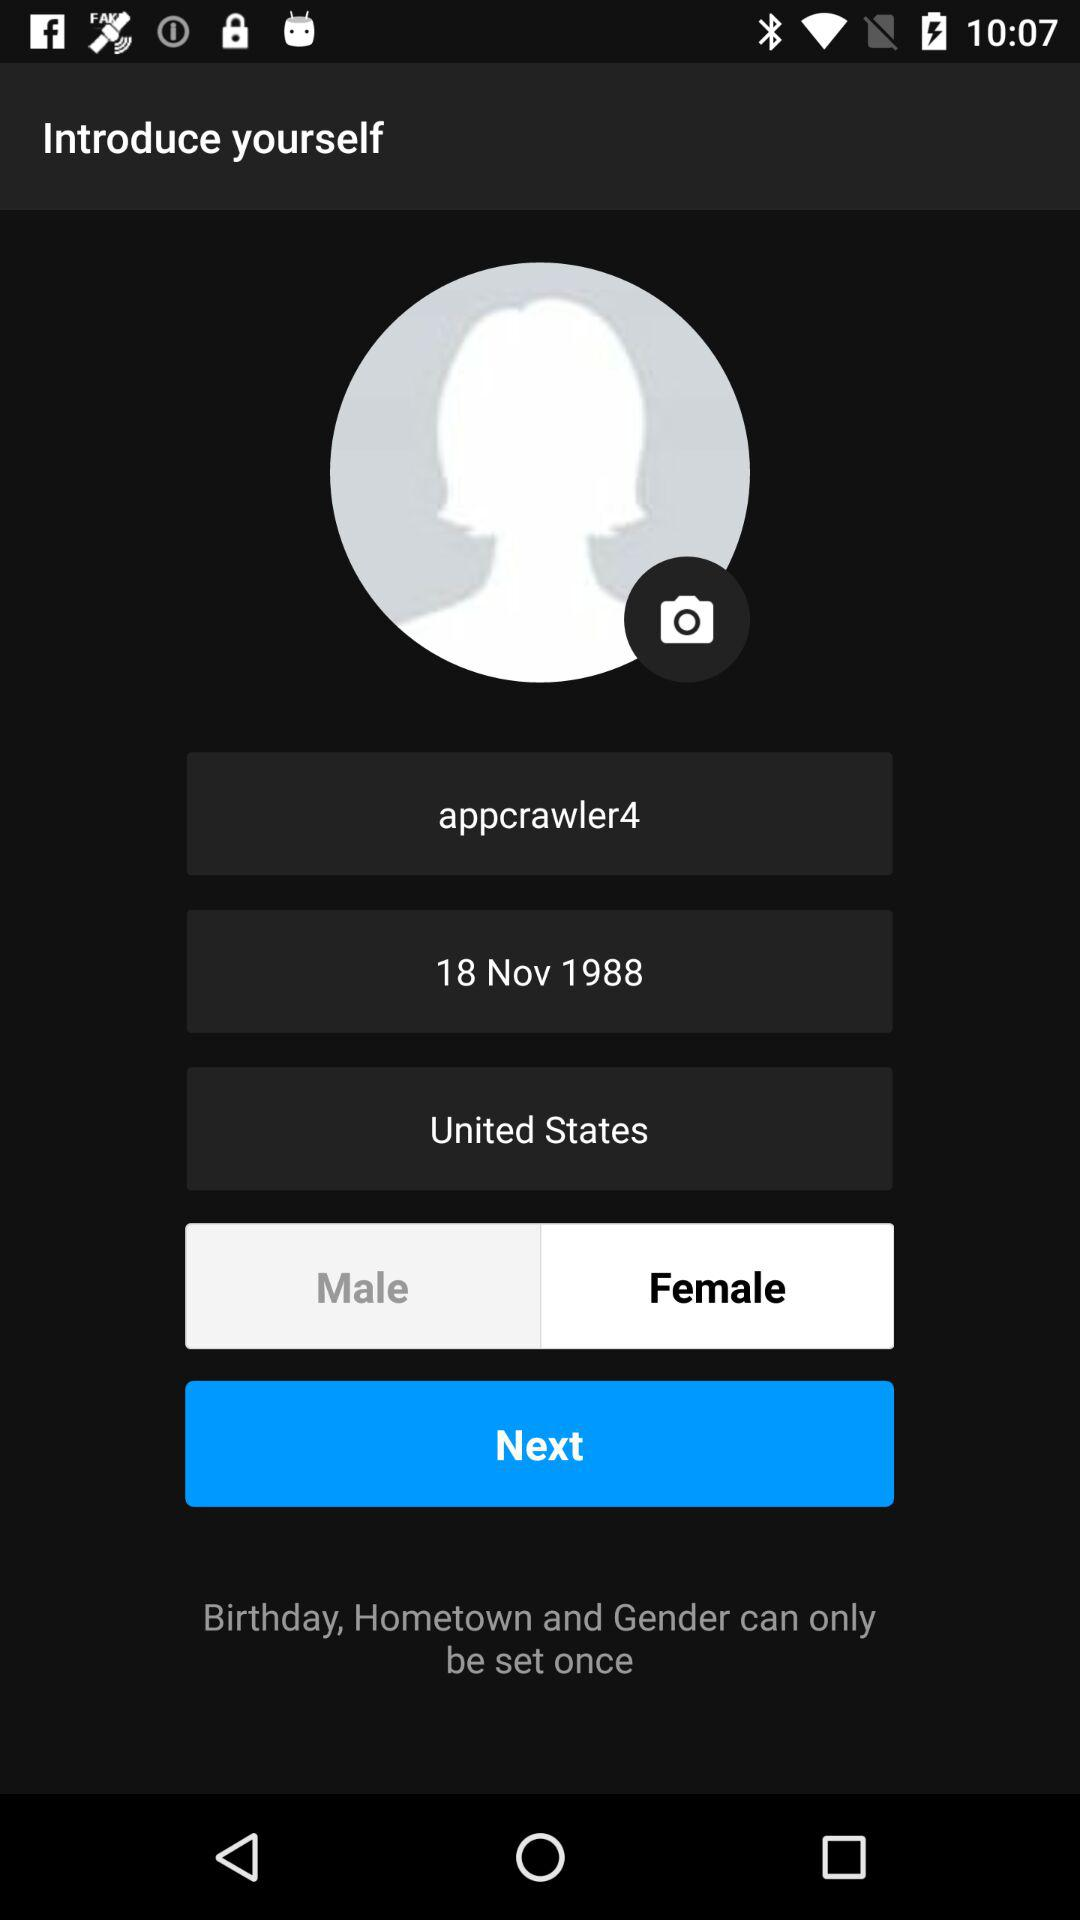What is the date of birth? The date of birth is November 18, 1988. 